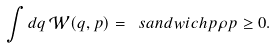Convert formula to latex. <formula><loc_0><loc_0><loc_500><loc_500>\int d q \, \mathcal { W } ( q , p ) = \ s a n d w i c h { p } { \rho } { p } \geq 0 .</formula> 